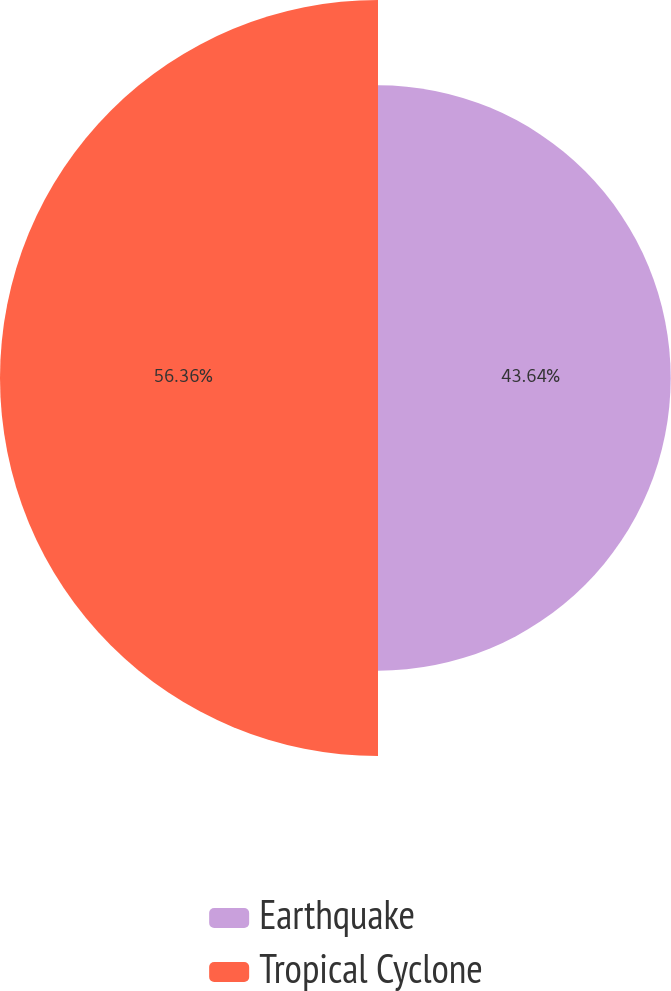Convert chart. <chart><loc_0><loc_0><loc_500><loc_500><pie_chart><fcel>Earthquake<fcel>Tropical Cyclone<nl><fcel>43.64%<fcel>56.36%<nl></chart> 